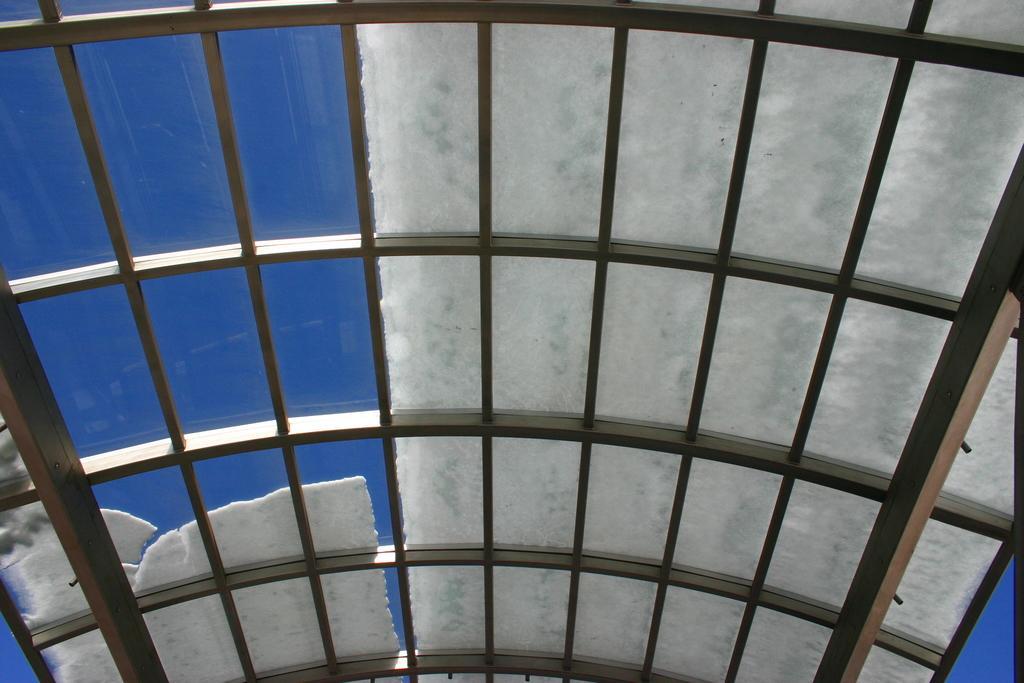Can you describe this image briefly? In the foreground of this image, it seems like a roof of a shed and some snow on it. 